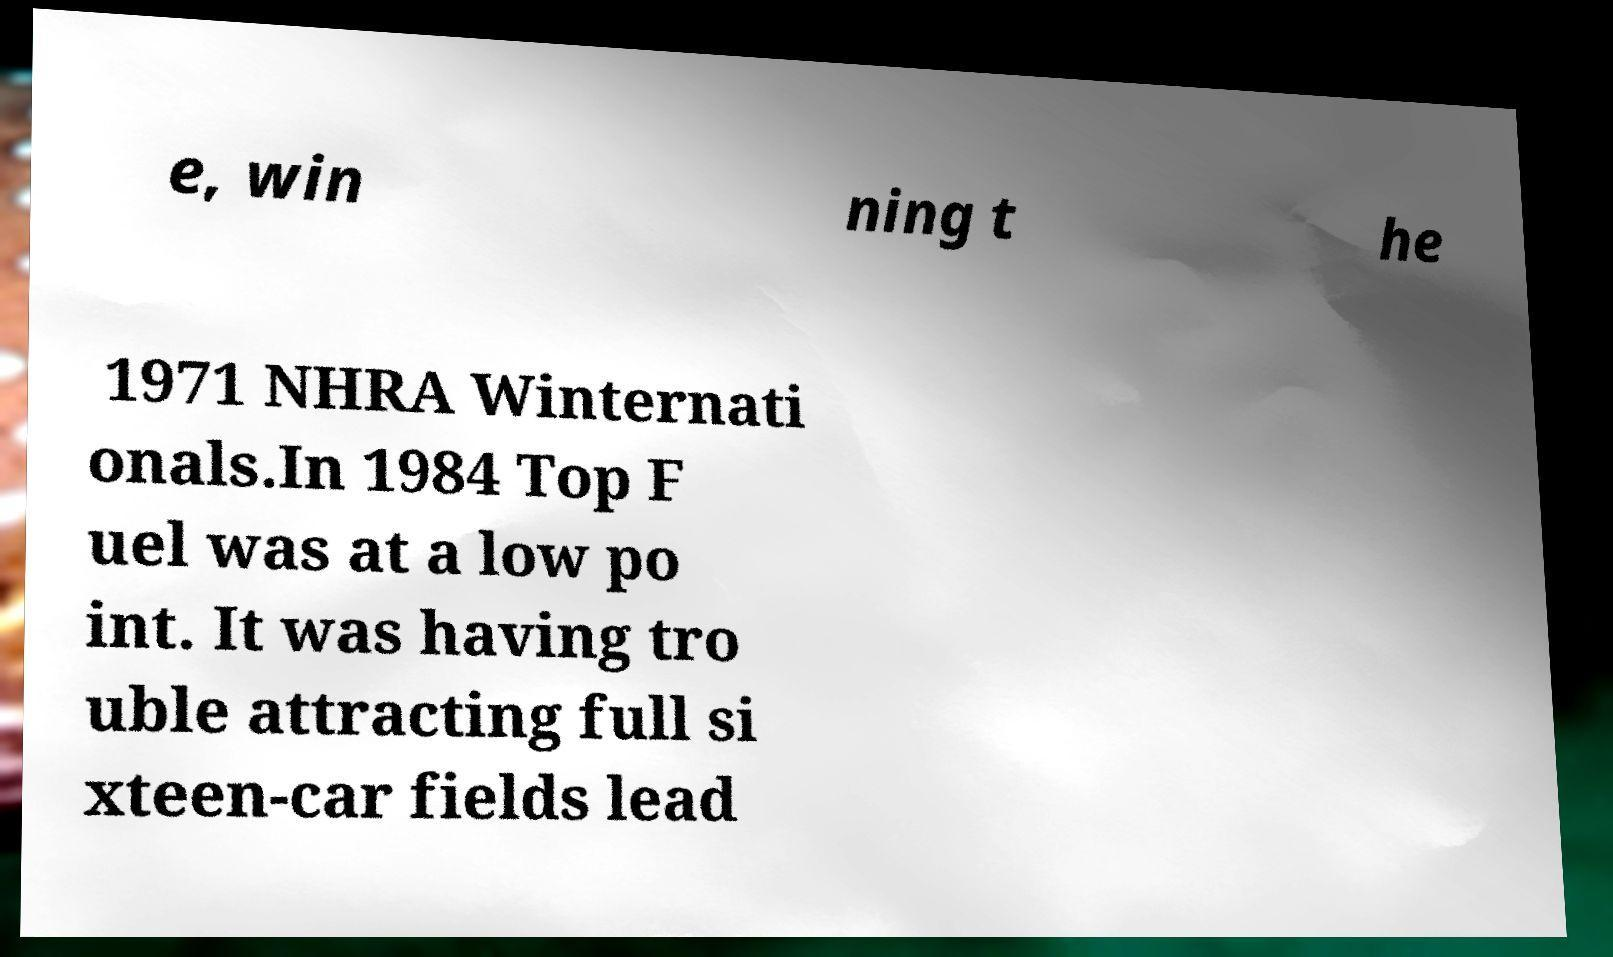Please read and relay the text visible in this image. What does it say? e, win ning t he 1971 NHRA Winternati onals.In 1984 Top F uel was at a low po int. It was having tro uble attracting full si xteen-car fields lead 